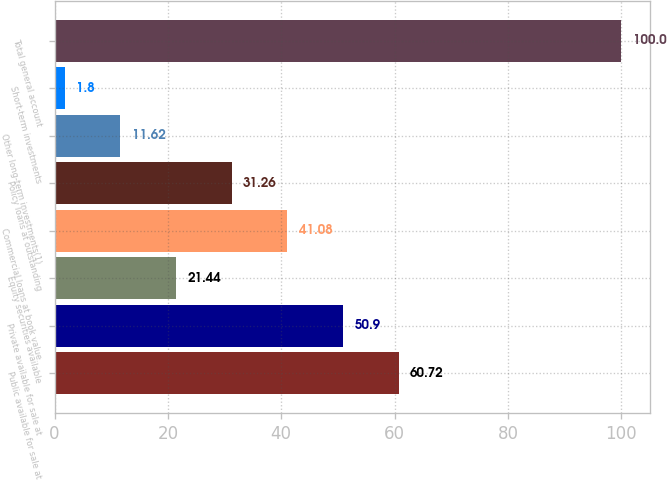Convert chart. <chart><loc_0><loc_0><loc_500><loc_500><bar_chart><fcel>Public available for sale at<fcel>Private available for sale at<fcel>Equity securities available<fcel>Commercial loans at book value<fcel>Policy loans at outstanding<fcel>Other long-term investments(1)<fcel>Short-term investments<fcel>Total general account<nl><fcel>60.72<fcel>50.9<fcel>21.44<fcel>41.08<fcel>31.26<fcel>11.62<fcel>1.8<fcel>100<nl></chart> 